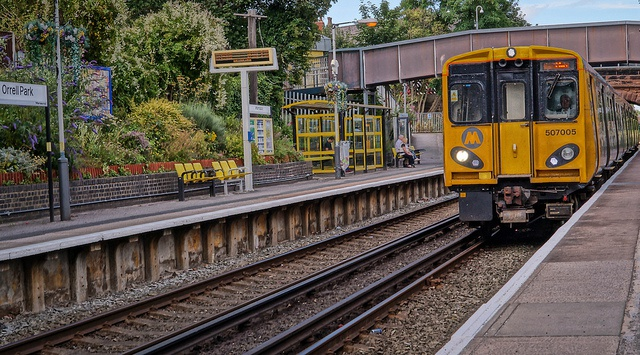Describe the objects in this image and their specific colors. I can see train in black, olive, gray, and orange tones, bench in black, olive, and tan tones, bench in black, darkgray, tan, and gray tones, people in black, gray, and purple tones, and bench in black, gray, darkgray, and olive tones in this image. 